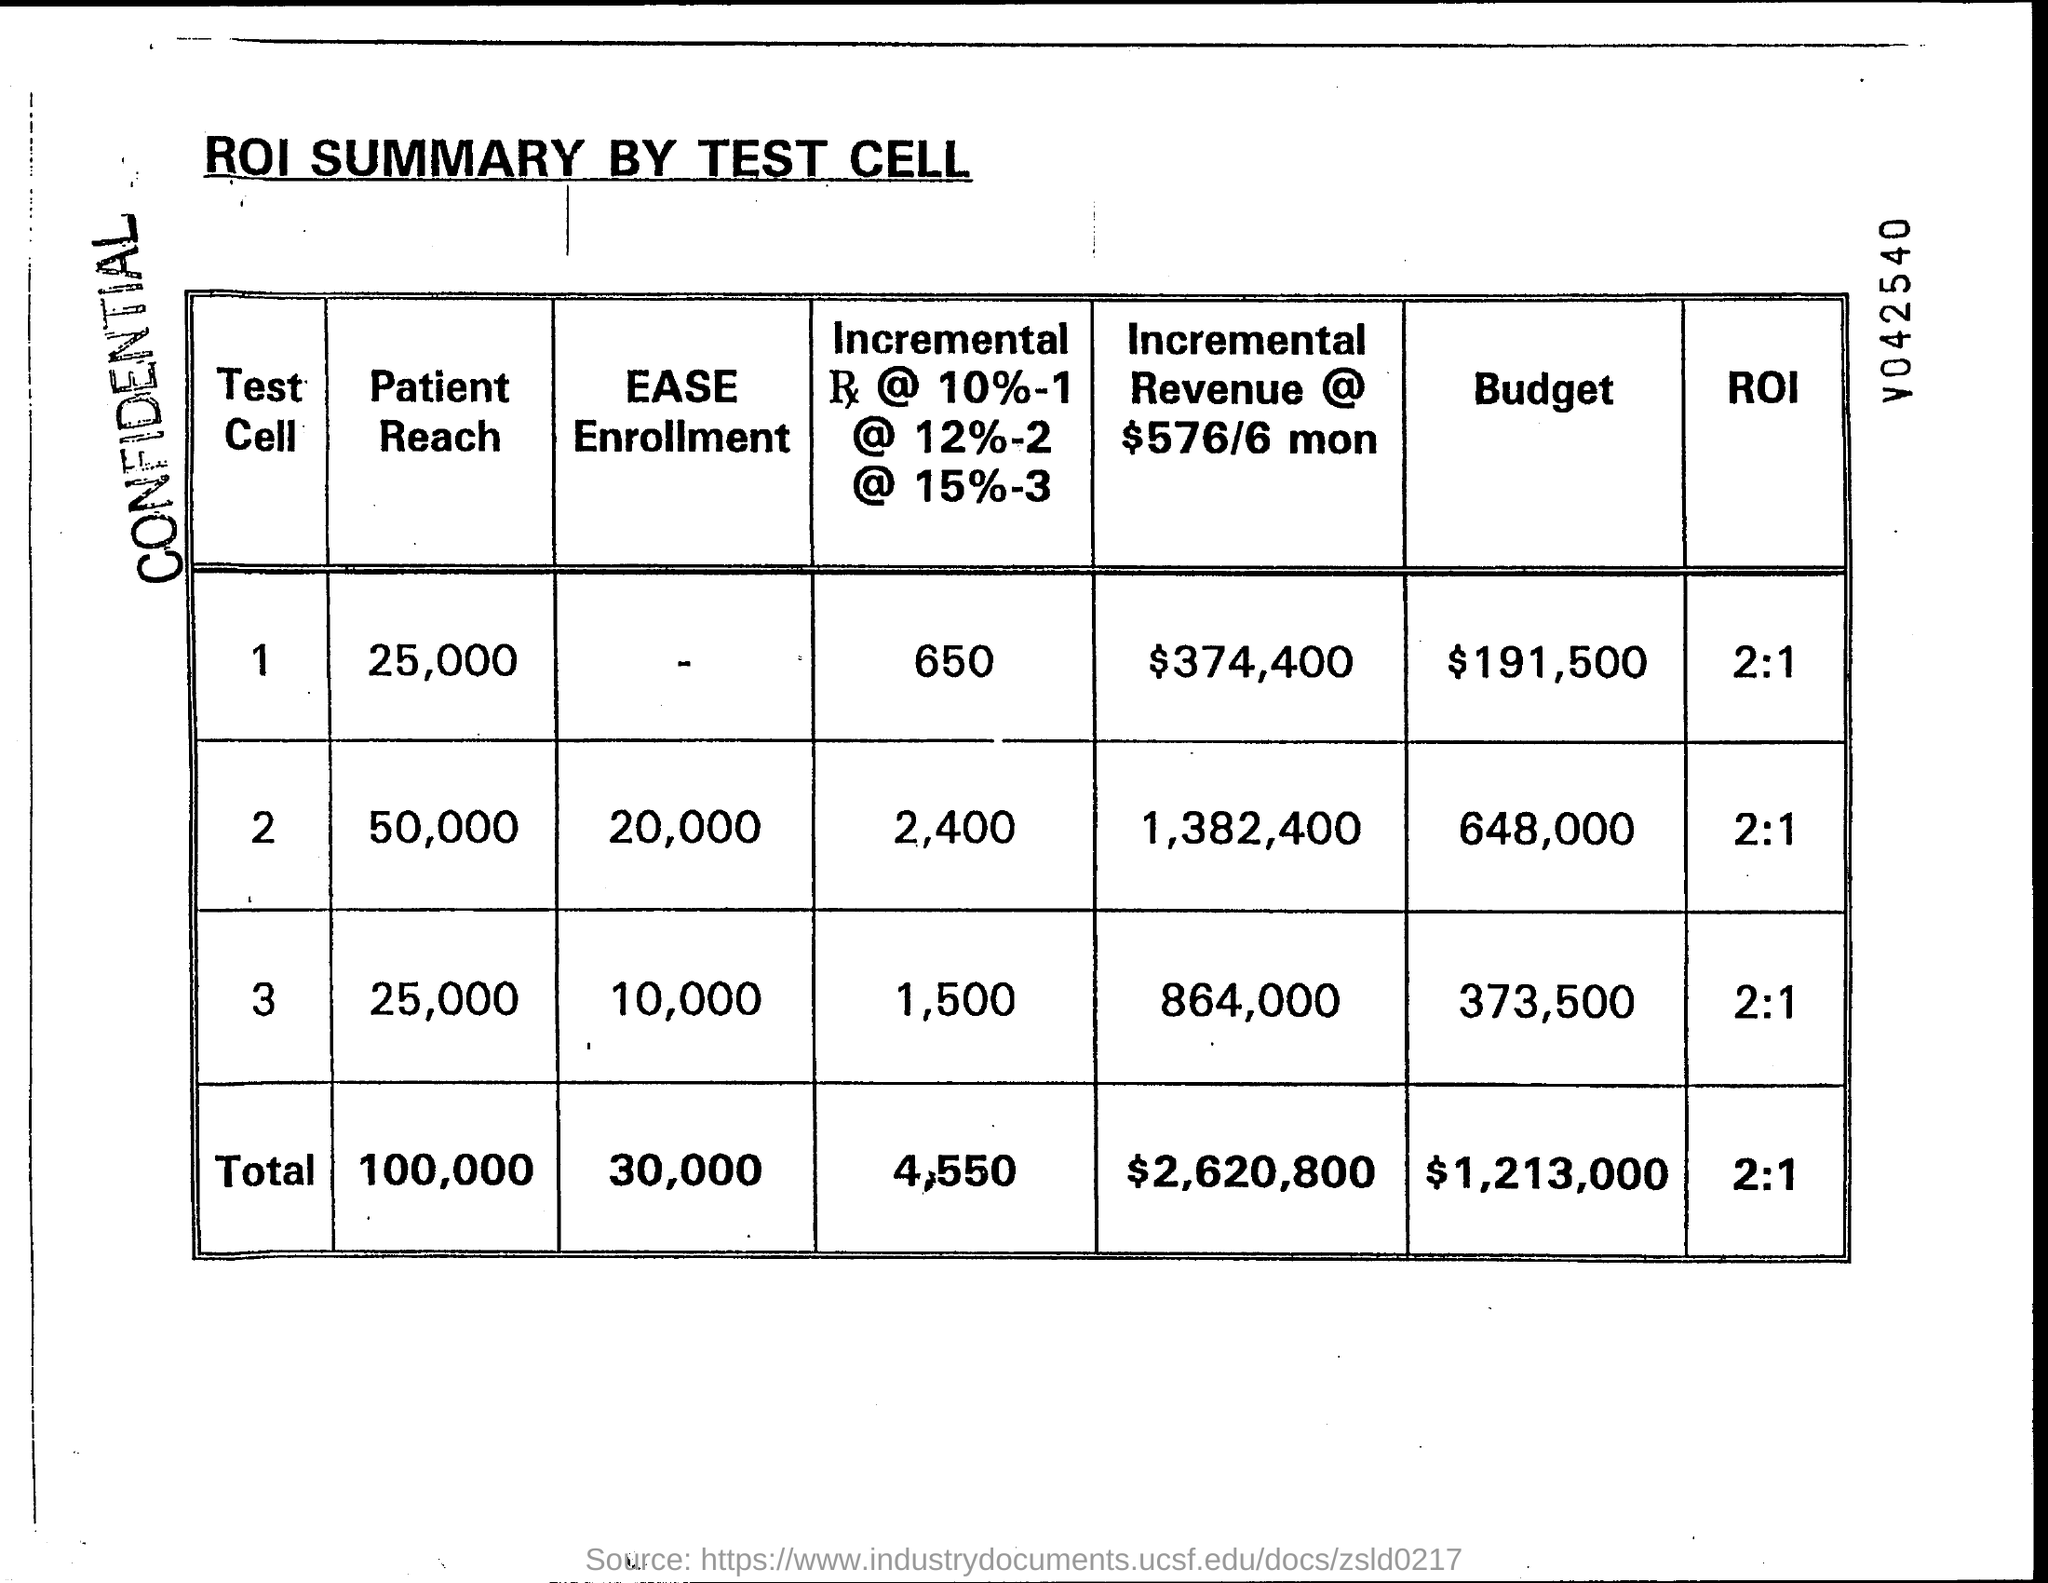How is the 'Incremental Revenue' calculated in this document? The 'Incremental Revenue' in the document seems to be calculated based on different percentage rates (10%, 12%, and 15%) applied to some aspect of the test cells. It appears to estimate the additional revenue generated by the tests at varying rates of return, indicating the potential financial benefit of the tests over a six-month period, as denoted by '6 mon'. 